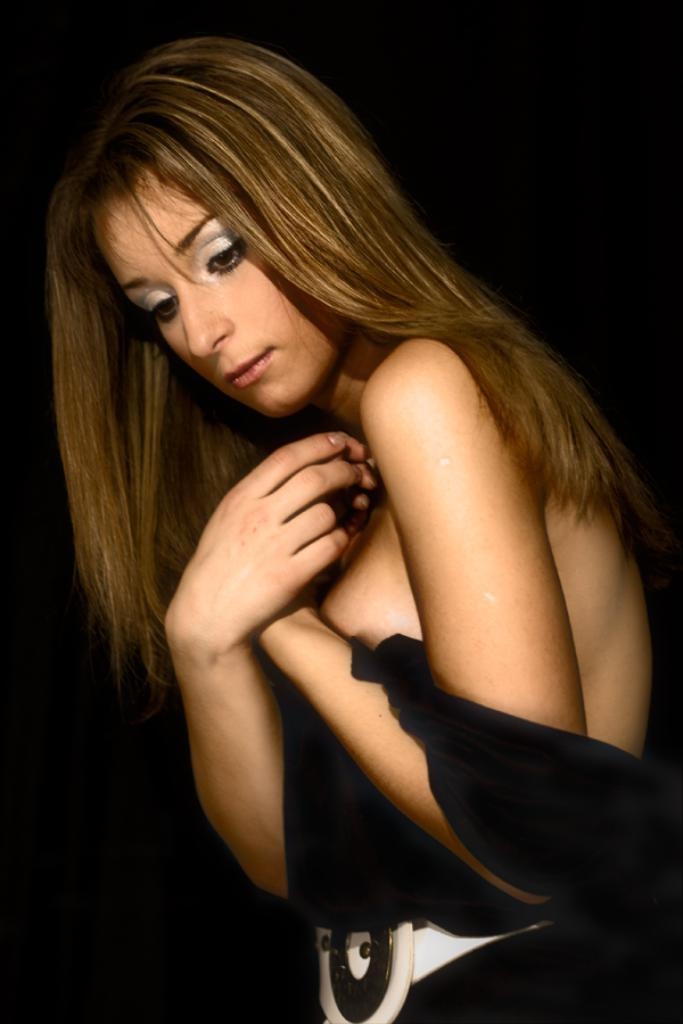Who is the main subject in the foreground of the image? There is a woman in the foreground of the image. How many letters are being folded by the woman in the image? There is no indication in the image that the woman is folding any letters, as the provided facts do not mention letters or folding. 